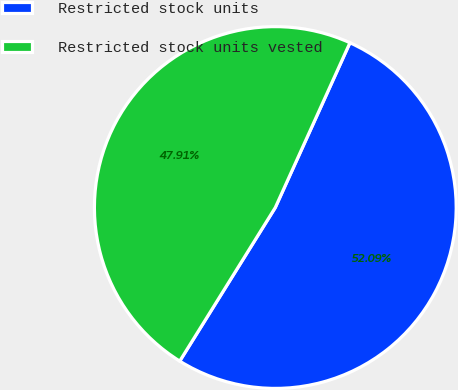Convert chart to OTSL. <chart><loc_0><loc_0><loc_500><loc_500><pie_chart><fcel>Restricted stock units<fcel>Restricted stock units vested<nl><fcel>52.09%<fcel>47.91%<nl></chart> 